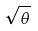<formula> <loc_0><loc_0><loc_500><loc_500>\sqrt { \theta }</formula> 